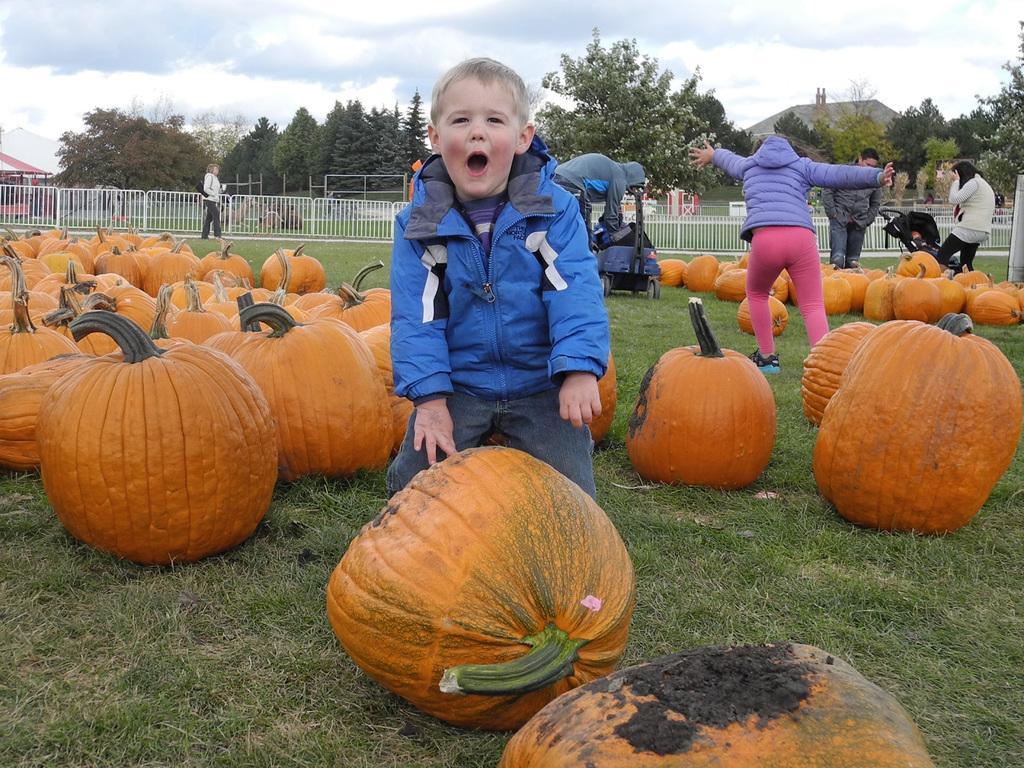Please provide a concise description of this image. The picture is taken in a ground. In the picture there pumpkins, people. In the background there are fencing, houses and trees. Sky is cloudy. 